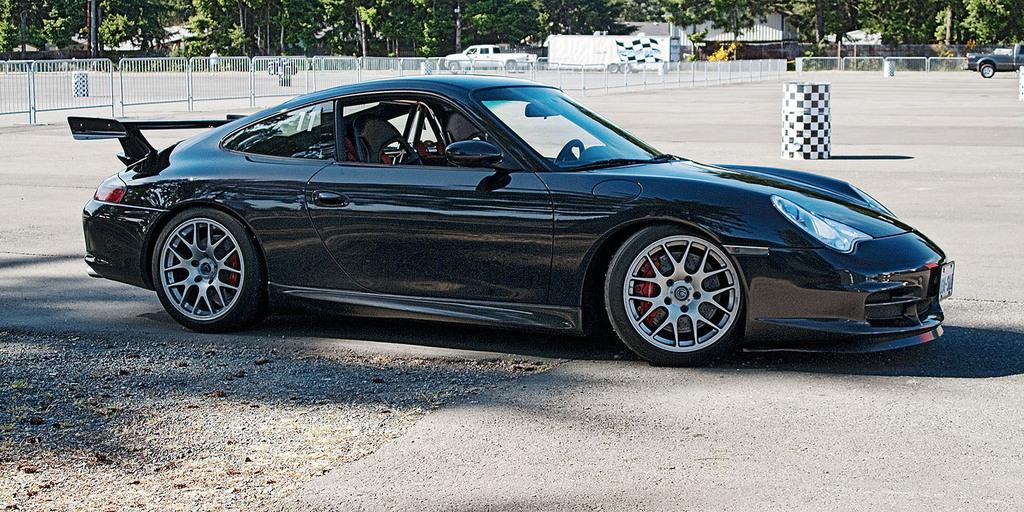What is the main subject in the foreground of the image? There is a car on the road in the foreground of the image. What can be seen in the background of the image? In the background of the image, there is fencing, drums, vehicles, trees, and buildings. Can you describe the type of vehicles in the background? The vehicles in the background are not specified, but they are present. What type of glue is being used to hold the chicken on the pump in the image? There is no chicken, pump, or glue present in the image. 